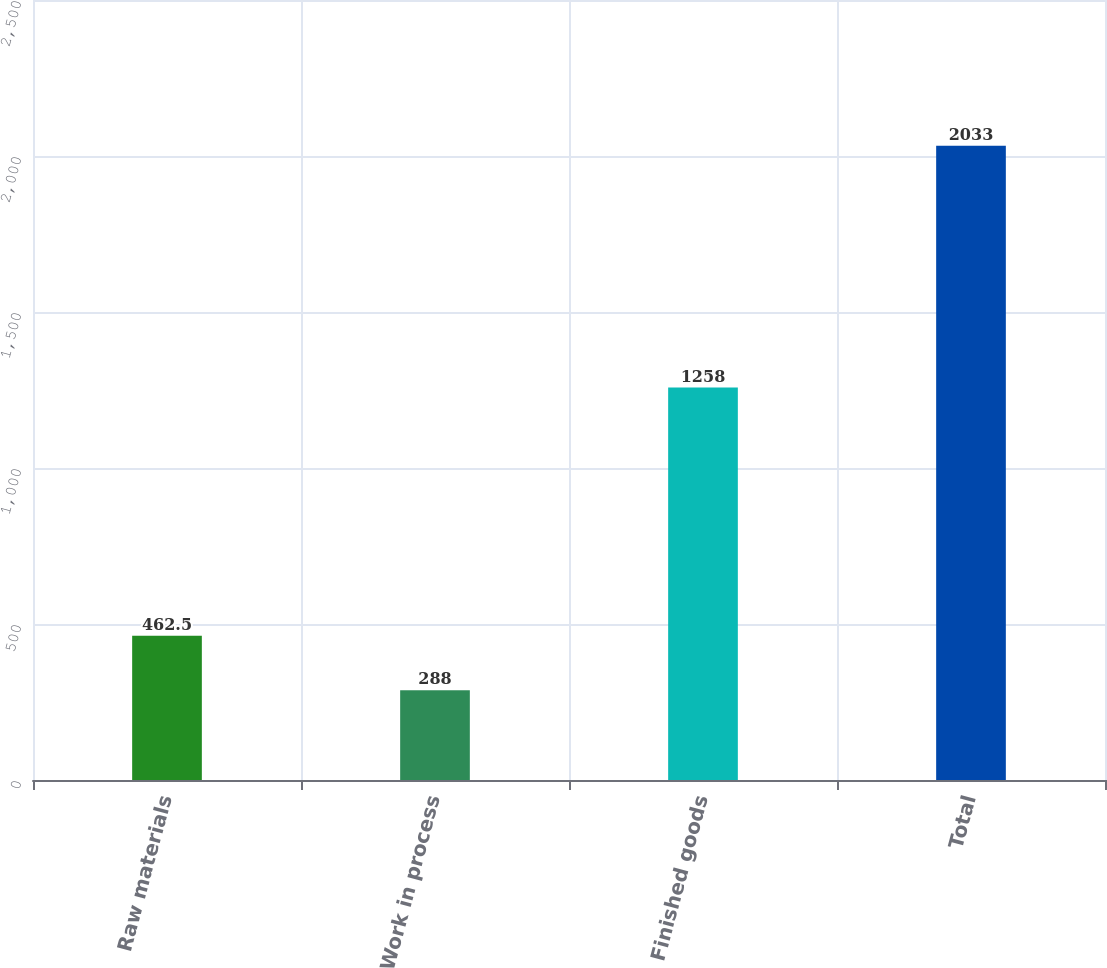Convert chart to OTSL. <chart><loc_0><loc_0><loc_500><loc_500><bar_chart><fcel>Raw materials<fcel>Work in process<fcel>Finished goods<fcel>Total<nl><fcel>462.5<fcel>288<fcel>1258<fcel>2033<nl></chart> 